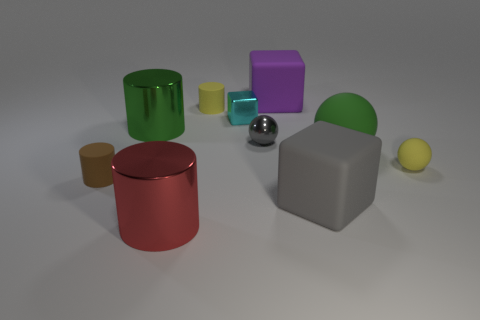Can you describe the lighting and shadows in the scene? The lighting in the scene is likely artificial, as indicated by the shadow patterns and the soft reflections on the objects. Each object casts a shadow directly opposite to where the light source is probable situated, suggesting that there may be a single primary light source illuminating the scene from above and slightly to the front left. The softness of the shadows indicates that the light source is diffused, resulting in a more even dispersal of light and soft transitions between light and dark areas. 